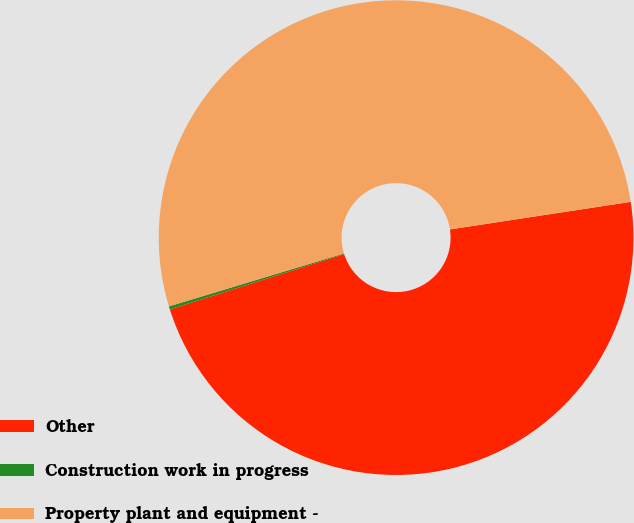Convert chart. <chart><loc_0><loc_0><loc_500><loc_500><pie_chart><fcel>Other<fcel>Construction work in progress<fcel>Property plant and equipment -<nl><fcel>47.52%<fcel>0.21%<fcel>52.27%<nl></chart> 